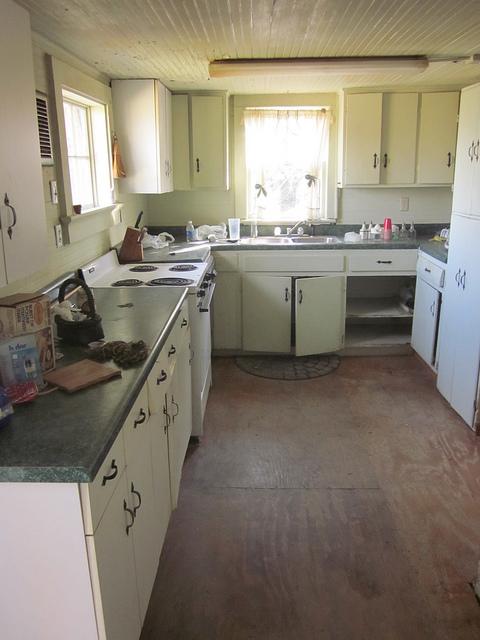What color are the countertops?
Quick response, please. Green. Is this a mobile kitchen?
Concise answer only. No. What color are the accent tiles?
Quick response, please. White. Are the cabinets open?
Write a very short answer. Yes. Is this room carpeted?
Write a very short answer. No. Is this "open concept"?
Give a very brief answer. No. Is this kitchen clean?
Keep it brief. No. What room is this?
Write a very short answer. Kitchen. 